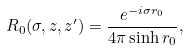<formula> <loc_0><loc_0><loc_500><loc_500>R _ { 0 } ( \sigma , z , z ^ { \prime } ) = \frac { e ^ { - i \sigma r _ { 0 } } } { 4 \pi \sinh r _ { 0 } } ,</formula> 